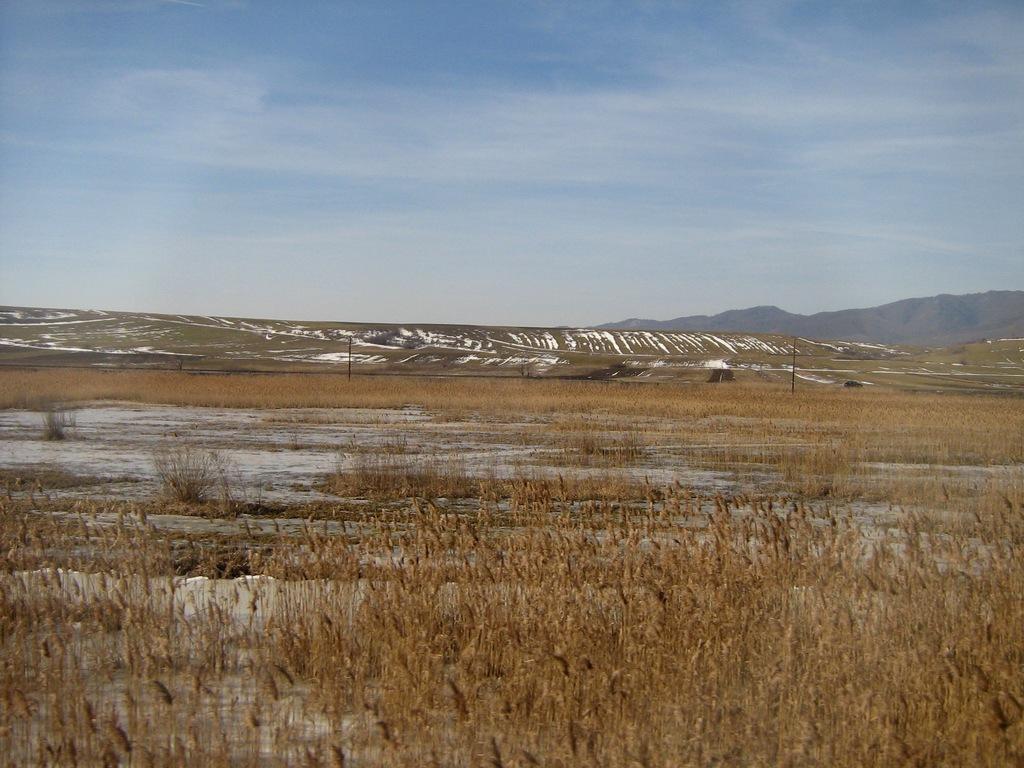Describe this image in one or two sentences. In this image, we can see plants on the ground and in the background, there are poles and hills and there is snow. At the top, there is sky. 